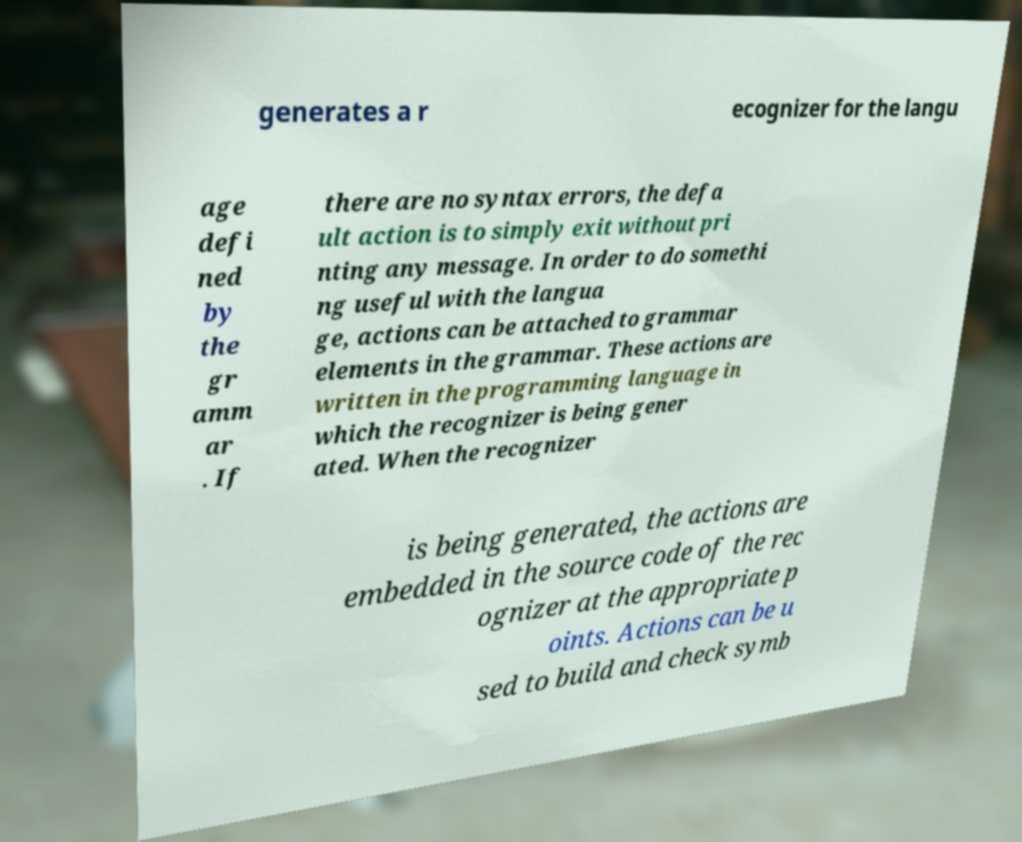I need the written content from this picture converted into text. Can you do that? generates a r ecognizer for the langu age defi ned by the gr amm ar . If there are no syntax errors, the defa ult action is to simply exit without pri nting any message. In order to do somethi ng useful with the langua ge, actions can be attached to grammar elements in the grammar. These actions are written in the programming language in which the recognizer is being gener ated. When the recognizer is being generated, the actions are embedded in the source code of the rec ognizer at the appropriate p oints. Actions can be u sed to build and check symb 